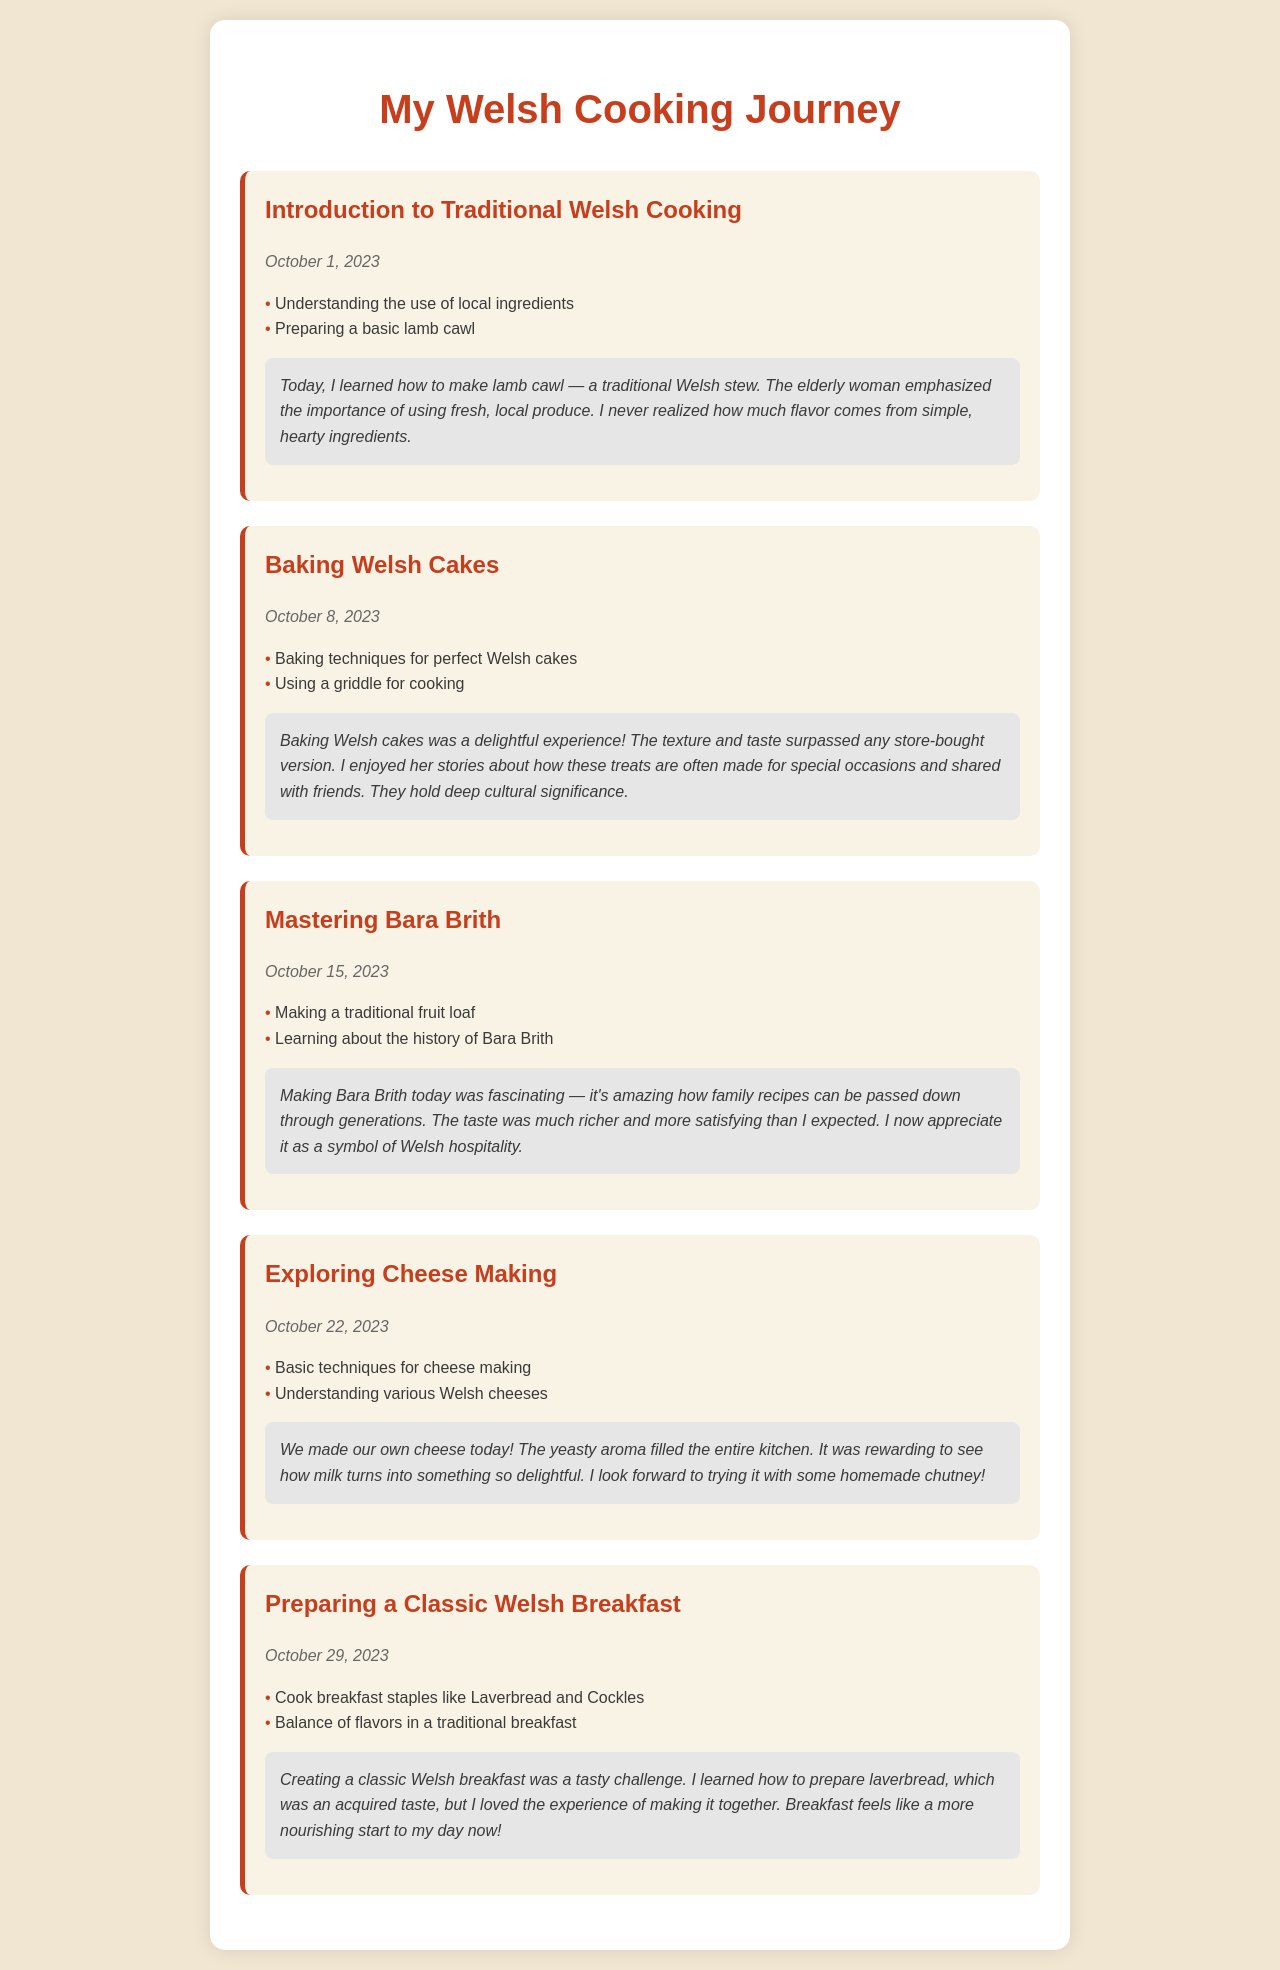What is the date of the first cooking session? The first cooking session is documented on October 1, 2023.
Answer: October 1, 2023 What dish did you prepare on October 8, 2023? On October 8, 2023, the dish prepared was Welsh cakes.
Answer: Welsh cakes How many cooking sessions are documented in total? There are five cooking sessions documented in the schedule.
Answer: Five What skill did you learn during the session on October 15, 2023? On October 15, 2023, you learned to make a traditional fruit loaf.
Answer: Making a traditional fruit loaf What is the main theme of the cooking journey documented? The main theme is learning traditional Welsh cooking from the elderly woman.
Answer: Traditional Welsh cooking Which cooking session involved making cheese? The session focusing on making cheese is dated October 22, 2023.
Answer: October 22, 2023 What ingredient is specifically mentioned in the preparation of a classic Welsh breakfast? Laverbread is specifically mentioned as a breakfast staple.
Answer: Laverbread What reflection was made about the flavor of the handmade cheese? The reflection stated that it was rewarding to see how milk turns into something so delightful.
Answer: Delightful What cultural significance do Welsh cakes hold? The elderly woman mentioned they are often made for special occasions and shared with friends.
Answer: Special occasions and sharing with friends 